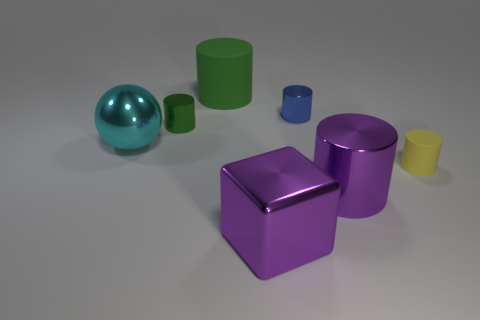There is a metal cylinder that is to the right of the green metallic cylinder and to the left of the purple cylinder; what is its size?
Ensure brevity in your answer.  Small. There is a cylinder that is the same color as the large cube; what is its material?
Provide a short and direct response. Metal. How many big blue metallic cylinders are there?
Make the answer very short. 0. Is the number of tiny things less than the number of purple cylinders?
Provide a short and direct response. No. There is a green thing that is the same size as the cyan metallic ball; what is it made of?
Provide a short and direct response. Rubber. How many things are either large cyan metal things or shiny objects?
Offer a terse response. 5. What number of big objects are on the left side of the big metal cylinder and in front of the small matte cylinder?
Provide a succinct answer. 1. Is the number of big green matte cylinders to the right of the tiny blue object less than the number of big blue metallic balls?
Your answer should be very brief. No. The matte thing that is the same size as the sphere is what shape?
Keep it short and to the point. Cylinder. What number of other objects are the same color as the tiny rubber object?
Provide a short and direct response. 0. 